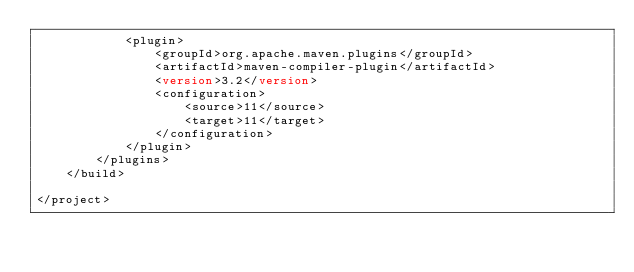<code> <loc_0><loc_0><loc_500><loc_500><_XML_>            <plugin>
                <groupId>org.apache.maven.plugins</groupId>
                <artifactId>maven-compiler-plugin</artifactId>
                <version>3.2</version>
                <configuration>
                    <source>11</source>
                    <target>11</target>
                </configuration>
            </plugin>
        </plugins>
    </build>

</project>
</code> 